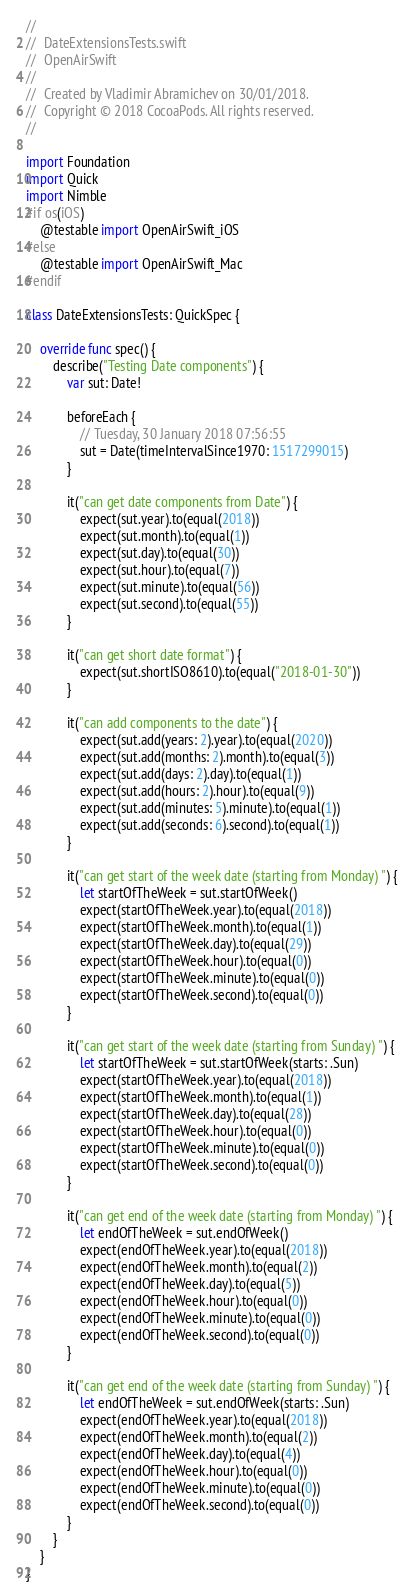<code> <loc_0><loc_0><loc_500><loc_500><_Swift_>//
//  DateExtensionsTests.swift
//  OpenAirSwift
//
//  Created by Vladimir Abramichev on 30/01/2018.
//  Copyright © 2018 CocoaPods. All rights reserved.
//

import Foundation
import Quick
import Nimble
#if os(iOS)
    @testable import OpenAirSwift_iOS
#else
    @testable import OpenAirSwift_Mac
#endif

class DateExtensionsTests: QuickSpec {
    
    override func spec() {
        describe("Testing Date components") {
            var sut: Date!
            
            beforeEach {
                // Tuesday, 30 January 2018 07:56:55
                sut = Date(timeIntervalSince1970: 1517299015)
            }
            
            it("can get date components from Date") {
                expect(sut.year).to(equal(2018))
                expect(sut.month).to(equal(1))
                expect(sut.day).to(equal(30))
                expect(sut.hour).to(equal(7))
                expect(sut.minute).to(equal(56))
                expect(sut.second).to(equal(55))
            }
            
            it("can get short date format") {
                expect(sut.shortISO8610).to(equal("2018-01-30"))
            }
            
            it("can add components to the date") {
                expect(sut.add(years: 2).year).to(equal(2020))
                expect(sut.add(months: 2).month).to(equal(3))
                expect(sut.add(days: 2).day).to(equal(1))
                expect(sut.add(hours: 2).hour).to(equal(9))
                expect(sut.add(minutes: 5).minute).to(equal(1))
                expect(sut.add(seconds: 6).second).to(equal(1))
            }
            
            it("can get start of the week date (starting from Monday) ") {
                let startOfTheWeek = sut.startOfWeek()
                expect(startOfTheWeek.year).to(equal(2018))
                expect(startOfTheWeek.month).to(equal(1))
                expect(startOfTheWeek.day).to(equal(29))
                expect(startOfTheWeek.hour).to(equal(0))
                expect(startOfTheWeek.minute).to(equal(0))
                expect(startOfTheWeek.second).to(equal(0))
            }
            
            it("can get start of the week date (starting from Sunday) ") {
                let startOfTheWeek = sut.startOfWeek(starts: .Sun)
                expect(startOfTheWeek.year).to(equal(2018))
                expect(startOfTheWeek.month).to(equal(1))
                expect(startOfTheWeek.day).to(equal(28))
                expect(startOfTheWeek.hour).to(equal(0))
                expect(startOfTheWeek.minute).to(equal(0))
                expect(startOfTheWeek.second).to(equal(0))
            }
            
            it("can get end of the week date (starting from Monday) ") {
                let endOfTheWeek = sut.endOfWeek()
                expect(endOfTheWeek.year).to(equal(2018))
                expect(endOfTheWeek.month).to(equal(2))
                expect(endOfTheWeek.day).to(equal(5))
                expect(endOfTheWeek.hour).to(equal(0))
                expect(endOfTheWeek.minute).to(equal(0))
                expect(endOfTheWeek.second).to(equal(0))
            }
            
            it("can get end of the week date (starting from Sunday) ") {
                let endOfTheWeek = sut.endOfWeek(starts: .Sun)
                expect(endOfTheWeek.year).to(equal(2018))
                expect(endOfTheWeek.month).to(equal(2))
                expect(endOfTheWeek.day).to(equal(4))
                expect(endOfTheWeek.hour).to(equal(0))
                expect(endOfTheWeek.minute).to(equal(0))
                expect(endOfTheWeek.second).to(equal(0))
            }
        }
    }
}

</code> 